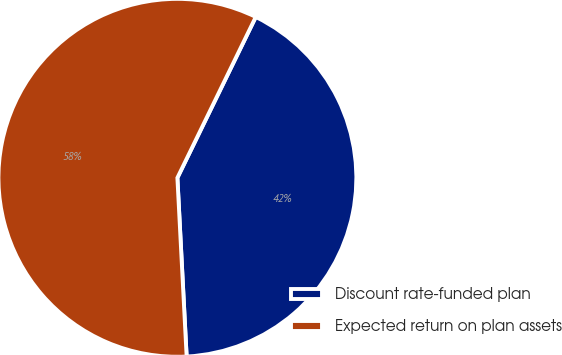Convert chart. <chart><loc_0><loc_0><loc_500><loc_500><pie_chart><fcel>Discount rate-funded plan<fcel>Expected return on plan assets<nl><fcel>41.96%<fcel>58.04%<nl></chart> 